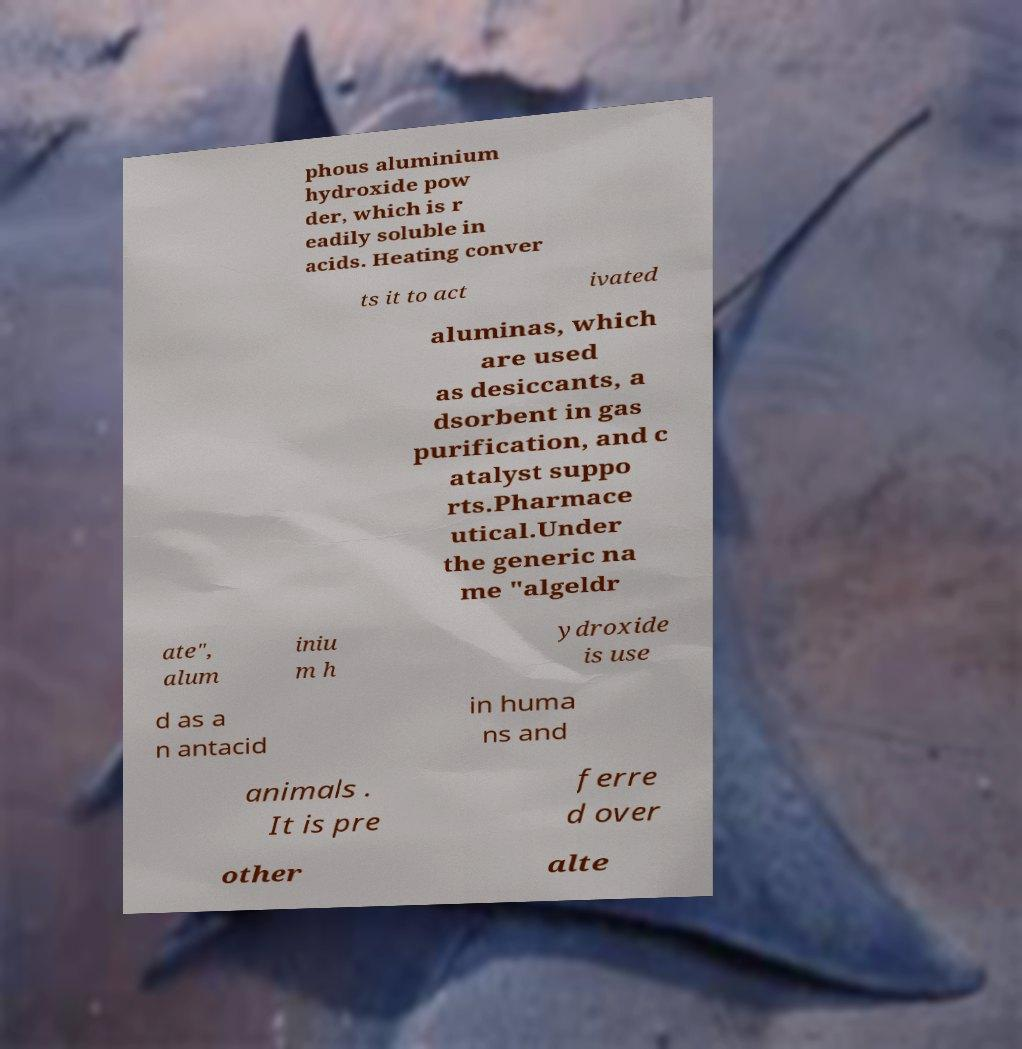Could you assist in decoding the text presented in this image and type it out clearly? phous aluminium hydroxide pow der, which is r eadily soluble in acids. Heating conver ts it to act ivated aluminas, which are used as desiccants, a dsorbent in gas purification, and c atalyst suppo rts.Pharmace utical.Under the generic na me "algeldr ate", alum iniu m h ydroxide is use d as a n antacid in huma ns and animals . It is pre ferre d over other alte 